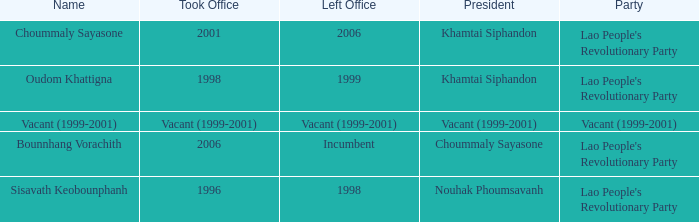What is Party, when Name is Oudom Khattigna? Lao People's Revolutionary Party. 